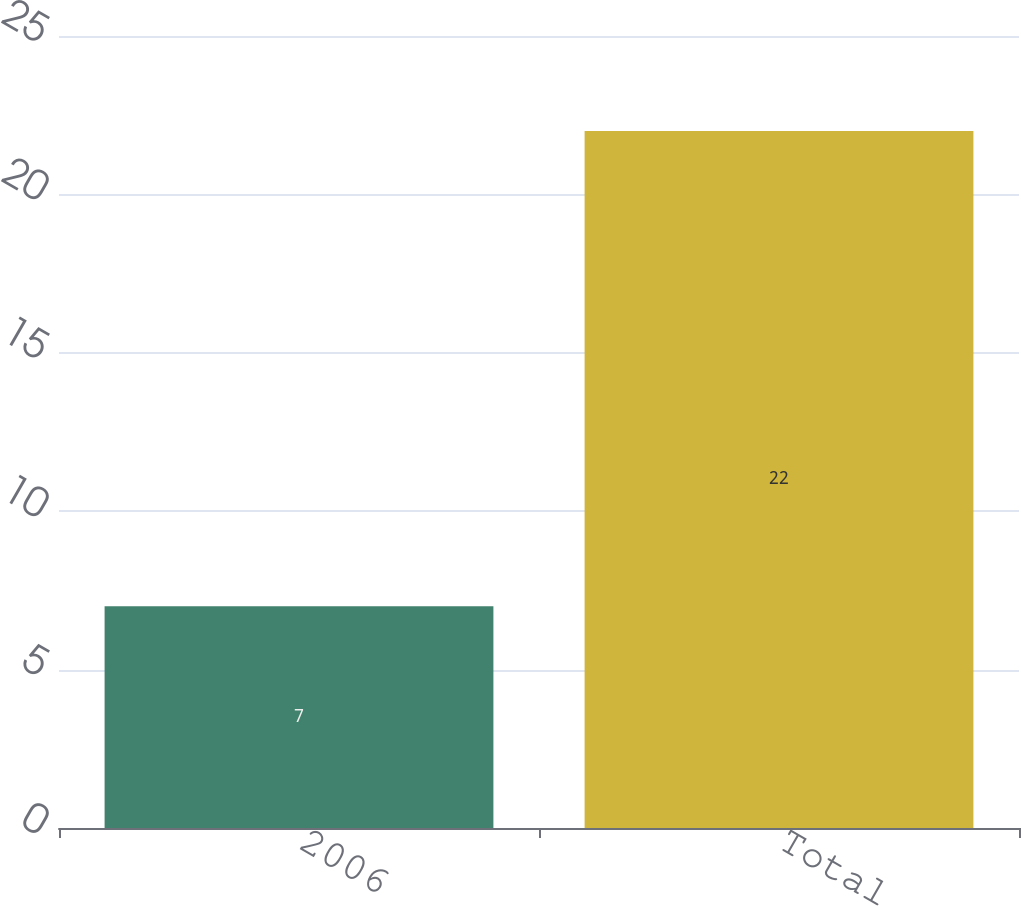<chart> <loc_0><loc_0><loc_500><loc_500><bar_chart><fcel>2006<fcel>Total<nl><fcel>7<fcel>22<nl></chart> 